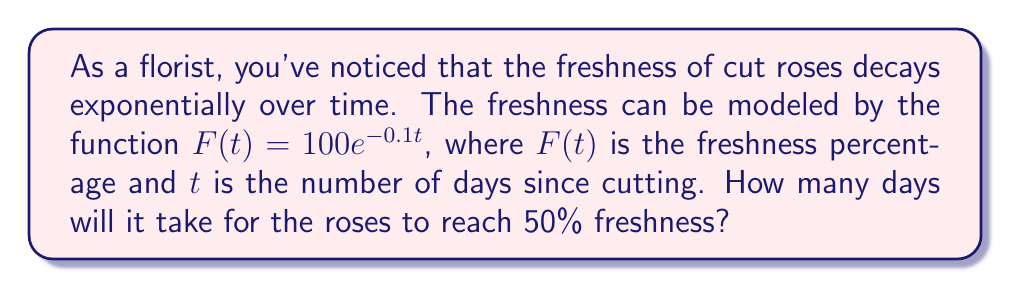Can you solve this math problem? To solve this problem, we'll use the given logarithmic function and follow these steps:

1) We're given the function $F(t) = 100e^{-0.1t}$
2) We want to find $t$ when $F(t) = 50$

3) Substitute the values into the equation:
   $50 = 100e^{-0.1t}$

4) Divide both sides by 100:
   $0.5 = e^{-0.1t}$

5) Take the natural logarithm of both sides:
   $\ln(0.5) = \ln(e^{-0.1t})$

6) Simplify the right side using the property of logarithms:
   $\ln(0.5) = -0.1t$

7) Divide both sides by -0.1:
   $\frac{\ln(0.5)}{-0.1} = t$

8) Calculate the value (use a calculator):
   $t \approx 6.93$ days

Therefore, it will take approximately 6.93 days for the roses to reach 50% freshness.
Answer: $6.93$ days 